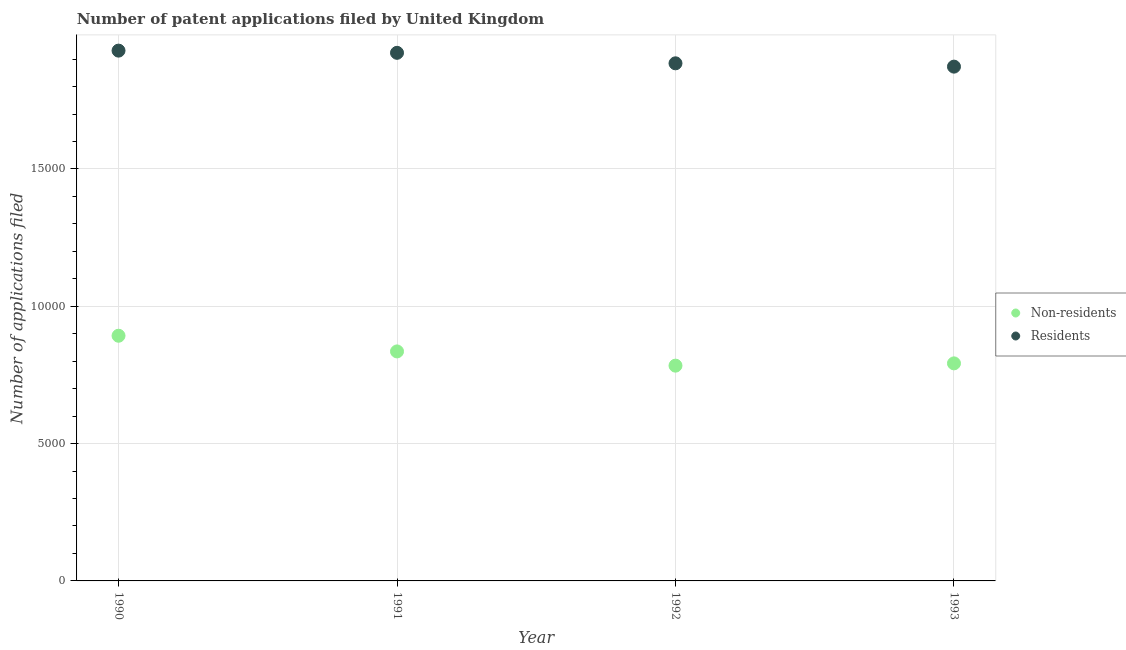How many different coloured dotlines are there?
Provide a succinct answer. 2. What is the number of patent applications by non residents in 1991?
Make the answer very short. 8357. Across all years, what is the maximum number of patent applications by non residents?
Your answer should be very brief. 8928. Across all years, what is the minimum number of patent applications by non residents?
Keep it short and to the point. 7839. What is the total number of patent applications by residents in the graph?
Give a very brief answer. 7.61e+04. What is the difference between the number of patent applications by residents in 1992 and that in 1993?
Keep it short and to the point. 121. What is the difference between the number of patent applications by residents in 1990 and the number of patent applications by non residents in 1991?
Give a very brief answer. 1.10e+04. What is the average number of patent applications by non residents per year?
Provide a succinct answer. 8261.5. In the year 1990, what is the difference between the number of patent applications by residents and number of patent applications by non residents?
Your response must be concise. 1.04e+04. In how many years, is the number of patent applications by residents greater than 6000?
Make the answer very short. 4. What is the ratio of the number of patent applications by non residents in 1991 to that in 1992?
Offer a terse response. 1.07. Is the number of patent applications by non residents in 1990 less than that in 1993?
Your answer should be very brief. No. What is the difference between the highest and the second highest number of patent applications by non residents?
Ensure brevity in your answer.  571. What is the difference between the highest and the lowest number of patent applications by non residents?
Your answer should be compact. 1089. Is the sum of the number of patent applications by residents in 1992 and 1993 greater than the maximum number of patent applications by non residents across all years?
Ensure brevity in your answer.  Yes. Does the number of patent applications by non residents monotonically increase over the years?
Your answer should be very brief. No. Is the number of patent applications by residents strictly less than the number of patent applications by non residents over the years?
Your response must be concise. No. How many dotlines are there?
Ensure brevity in your answer.  2. Does the graph contain any zero values?
Offer a terse response. No. Does the graph contain grids?
Ensure brevity in your answer.  Yes. How many legend labels are there?
Offer a terse response. 2. What is the title of the graph?
Your response must be concise. Number of patent applications filed by United Kingdom. What is the label or title of the Y-axis?
Offer a terse response. Number of applications filed. What is the Number of applications filed in Non-residents in 1990?
Keep it short and to the point. 8928. What is the Number of applications filed of Residents in 1990?
Give a very brief answer. 1.93e+04. What is the Number of applications filed of Non-residents in 1991?
Provide a succinct answer. 8357. What is the Number of applications filed of Residents in 1991?
Make the answer very short. 1.92e+04. What is the Number of applications filed of Non-residents in 1992?
Make the answer very short. 7839. What is the Number of applications filed in Residents in 1992?
Your answer should be very brief. 1.88e+04. What is the Number of applications filed of Non-residents in 1993?
Give a very brief answer. 7922. What is the Number of applications filed of Residents in 1993?
Your answer should be very brief. 1.87e+04. Across all years, what is the maximum Number of applications filed of Non-residents?
Ensure brevity in your answer.  8928. Across all years, what is the maximum Number of applications filed of Residents?
Provide a short and direct response. 1.93e+04. Across all years, what is the minimum Number of applications filed in Non-residents?
Offer a very short reply. 7839. Across all years, what is the minimum Number of applications filed of Residents?
Offer a very short reply. 1.87e+04. What is the total Number of applications filed of Non-residents in the graph?
Provide a short and direct response. 3.30e+04. What is the total Number of applications filed of Residents in the graph?
Your answer should be compact. 7.61e+04. What is the difference between the Number of applications filed of Non-residents in 1990 and that in 1991?
Give a very brief answer. 571. What is the difference between the Number of applications filed in Non-residents in 1990 and that in 1992?
Your response must be concise. 1089. What is the difference between the Number of applications filed of Residents in 1990 and that in 1992?
Make the answer very short. 462. What is the difference between the Number of applications filed in Non-residents in 1990 and that in 1993?
Ensure brevity in your answer.  1006. What is the difference between the Number of applications filed in Residents in 1990 and that in 1993?
Give a very brief answer. 583. What is the difference between the Number of applications filed in Non-residents in 1991 and that in 1992?
Make the answer very short. 518. What is the difference between the Number of applications filed in Residents in 1991 and that in 1992?
Make the answer very short. 382. What is the difference between the Number of applications filed in Non-residents in 1991 and that in 1993?
Your response must be concise. 435. What is the difference between the Number of applications filed in Residents in 1991 and that in 1993?
Your answer should be compact. 503. What is the difference between the Number of applications filed in Non-residents in 1992 and that in 1993?
Give a very brief answer. -83. What is the difference between the Number of applications filed in Residents in 1992 and that in 1993?
Offer a terse response. 121. What is the difference between the Number of applications filed in Non-residents in 1990 and the Number of applications filed in Residents in 1991?
Your response must be concise. -1.03e+04. What is the difference between the Number of applications filed in Non-residents in 1990 and the Number of applications filed in Residents in 1992?
Make the answer very short. -9920. What is the difference between the Number of applications filed of Non-residents in 1990 and the Number of applications filed of Residents in 1993?
Your answer should be compact. -9799. What is the difference between the Number of applications filed of Non-residents in 1991 and the Number of applications filed of Residents in 1992?
Provide a short and direct response. -1.05e+04. What is the difference between the Number of applications filed of Non-residents in 1991 and the Number of applications filed of Residents in 1993?
Your answer should be compact. -1.04e+04. What is the difference between the Number of applications filed of Non-residents in 1992 and the Number of applications filed of Residents in 1993?
Make the answer very short. -1.09e+04. What is the average Number of applications filed of Non-residents per year?
Give a very brief answer. 8261.5. What is the average Number of applications filed in Residents per year?
Offer a very short reply. 1.90e+04. In the year 1990, what is the difference between the Number of applications filed of Non-residents and Number of applications filed of Residents?
Keep it short and to the point. -1.04e+04. In the year 1991, what is the difference between the Number of applications filed in Non-residents and Number of applications filed in Residents?
Make the answer very short. -1.09e+04. In the year 1992, what is the difference between the Number of applications filed of Non-residents and Number of applications filed of Residents?
Provide a short and direct response. -1.10e+04. In the year 1993, what is the difference between the Number of applications filed of Non-residents and Number of applications filed of Residents?
Give a very brief answer. -1.08e+04. What is the ratio of the Number of applications filed of Non-residents in 1990 to that in 1991?
Make the answer very short. 1.07. What is the ratio of the Number of applications filed in Residents in 1990 to that in 1991?
Offer a very short reply. 1. What is the ratio of the Number of applications filed in Non-residents in 1990 to that in 1992?
Your answer should be very brief. 1.14. What is the ratio of the Number of applications filed in Residents in 1990 to that in 1992?
Make the answer very short. 1.02. What is the ratio of the Number of applications filed of Non-residents in 1990 to that in 1993?
Provide a succinct answer. 1.13. What is the ratio of the Number of applications filed in Residents in 1990 to that in 1993?
Ensure brevity in your answer.  1.03. What is the ratio of the Number of applications filed in Non-residents in 1991 to that in 1992?
Your answer should be compact. 1.07. What is the ratio of the Number of applications filed in Residents in 1991 to that in 1992?
Offer a terse response. 1.02. What is the ratio of the Number of applications filed in Non-residents in 1991 to that in 1993?
Ensure brevity in your answer.  1.05. What is the ratio of the Number of applications filed in Residents in 1991 to that in 1993?
Offer a terse response. 1.03. What is the ratio of the Number of applications filed in Non-residents in 1992 to that in 1993?
Keep it short and to the point. 0.99. What is the difference between the highest and the second highest Number of applications filed in Non-residents?
Your answer should be compact. 571. What is the difference between the highest and the lowest Number of applications filed in Non-residents?
Your answer should be compact. 1089. What is the difference between the highest and the lowest Number of applications filed of Residents?
Provide a short and direct response. 583. 